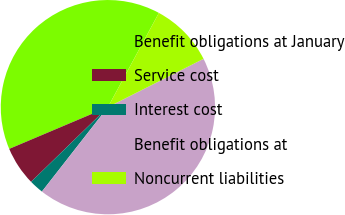Convert chart to OTSL. <chart><loc_0><loc_0><loc_500><loc_500><pie_chart><fcel>Benefit obligations at January<fcel>Service cost<fcel>Interest cost<fcel>Benefit obligations at<fcel>Noncurrent liabilities<nl><fcel>39.26%<fcel>5.91%<fcel>2.16%<fcel>43.01%<fcel>9.66%<nl></chart> 